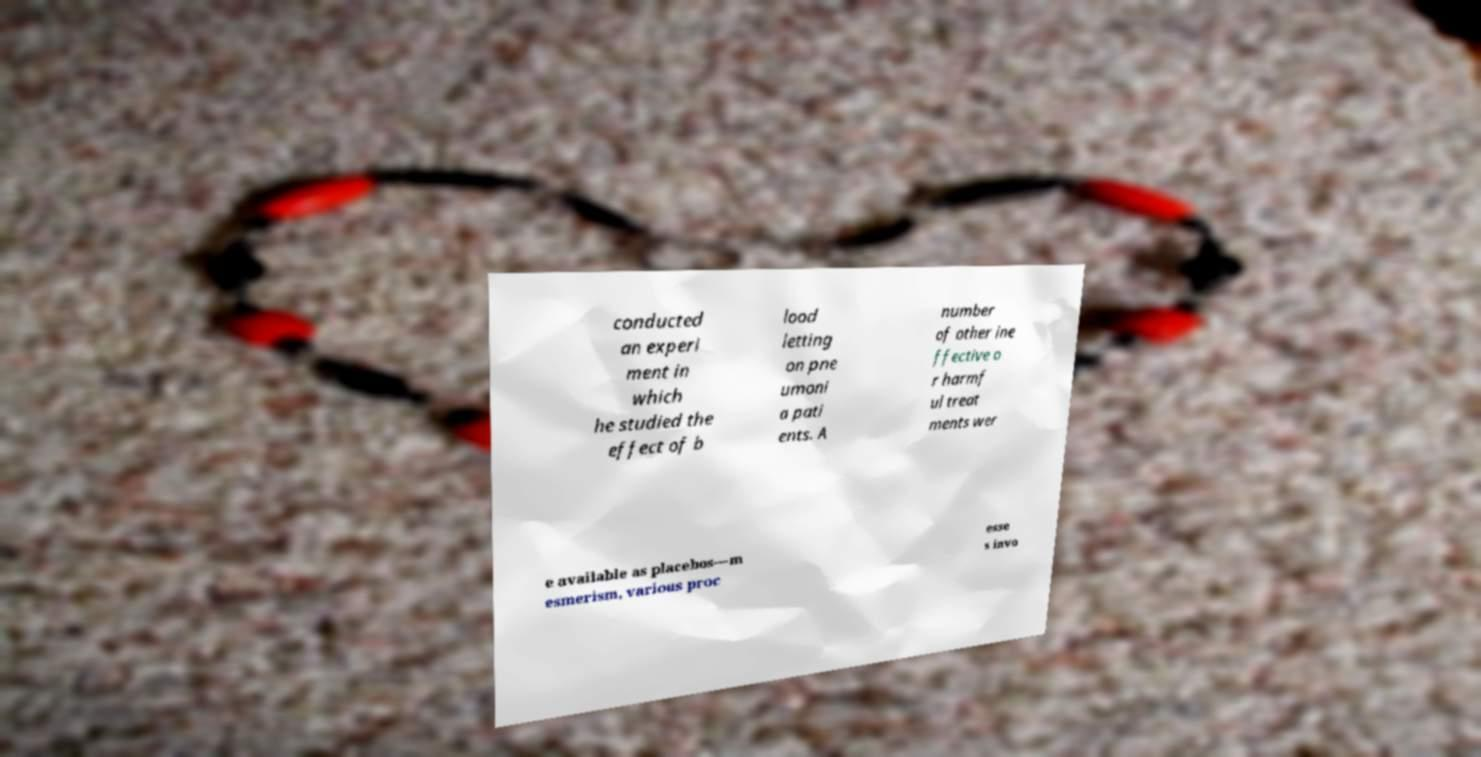What messages or text are displayed in this image? I need them in a readable, typed format. conducted an experi ment in which he studied the effect of b lood letting on pne umoni a pati ents. A number of other ine ffective o r harmf ul treat ments wer e available as placebos—m esmerism, various proc esse s invo 